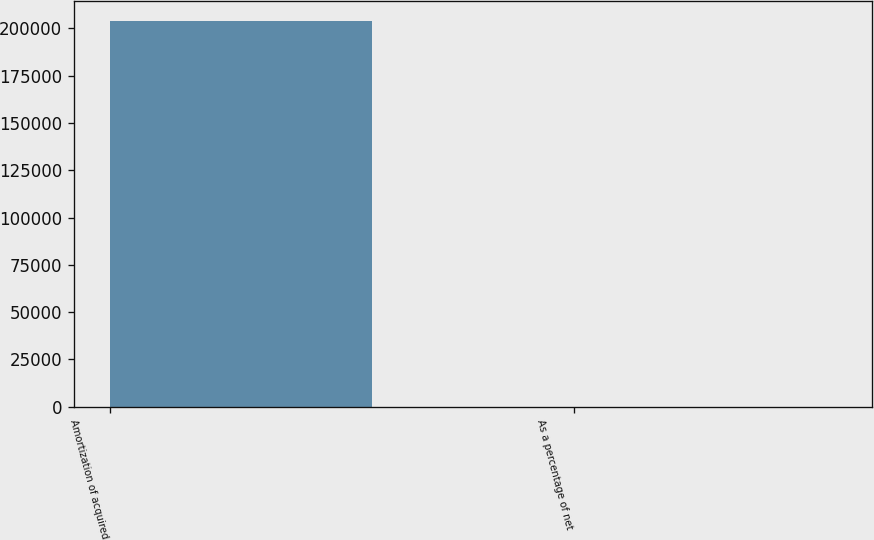<chart> <loc_0><loc_0><loc_500><loc_500><bar_chart><fcel>Amortization of acquired<fcel>As a percentage of net<nl><fcel>204104<fcel>2.7<nl></chart> 